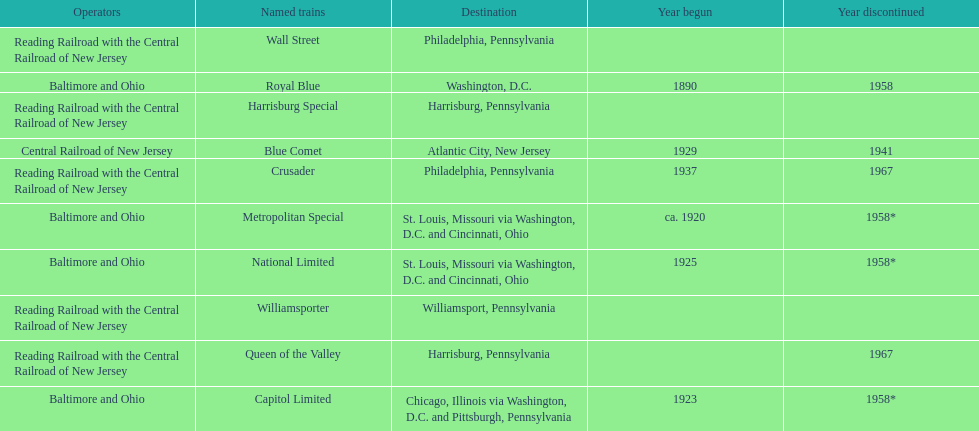Which other traine, other than wall street, had philadelphia as a destination? Crusader. 